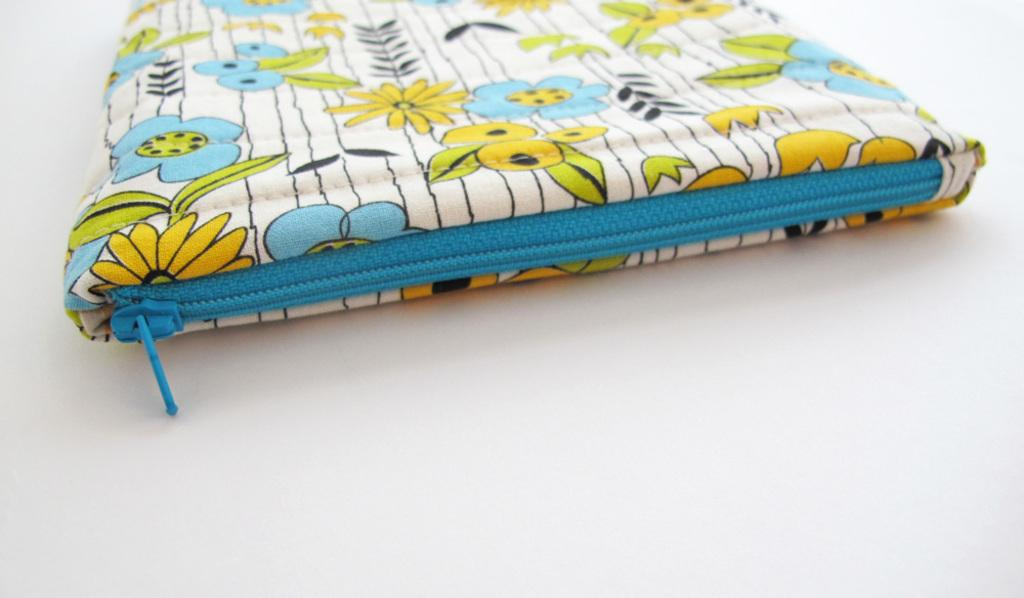What object is present in the image? There is a pouch in the image. What colors can be seen on the pouch? The pouch has white, yellow, green, blue, and black colors. What feature is used to close the pouch? The pouch has a blue zip. Where is the pouch located in the image? The pouch is on a white floor. How many cars are parked near the pouch in the image? There are no cars present in the image; it only features a pouch on a white floor. Can you see a clam near the pouch in the image? There is no clam present in the image; it only features a pouch on a white floor. 